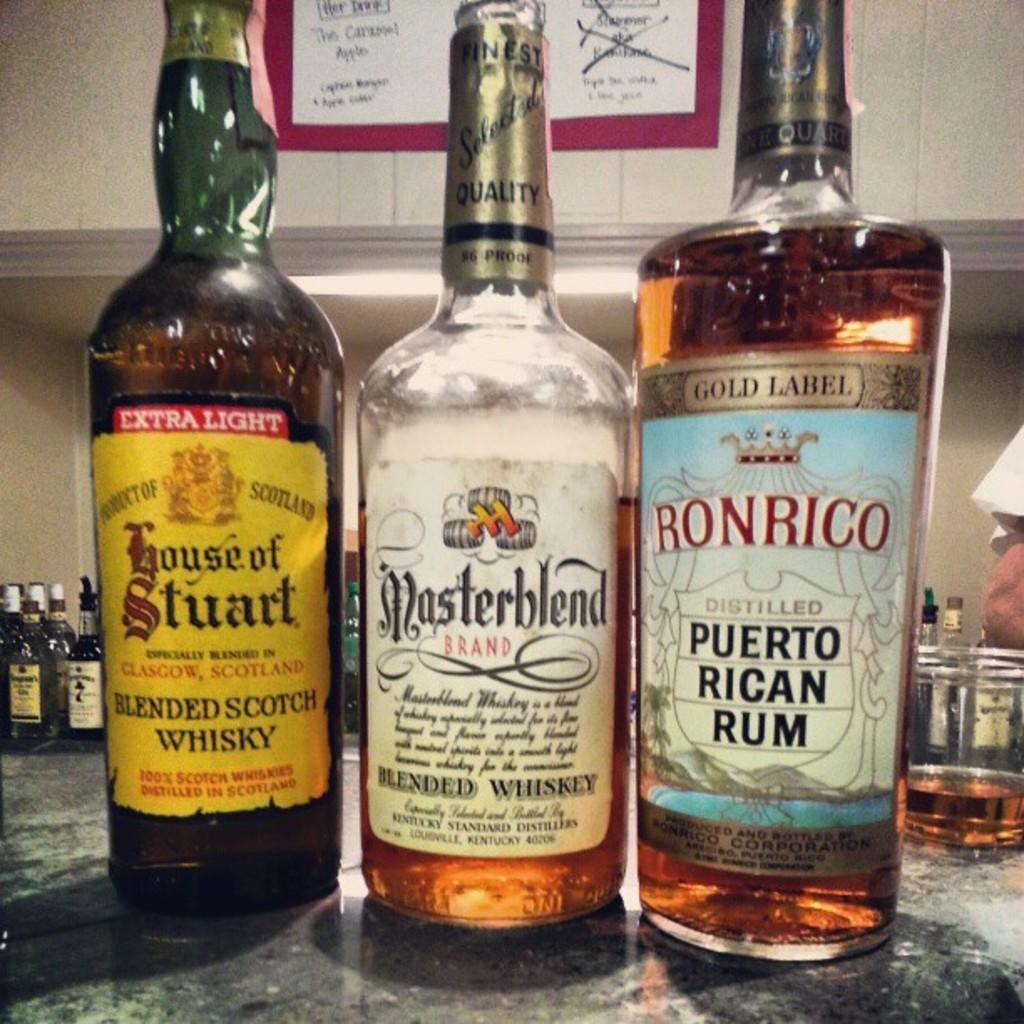<image>
Share a concise interpretation of the image provided. Three bottles of alcohol with different brands like ronrico, masterblend and house of stuart are sitting next to each oter. 